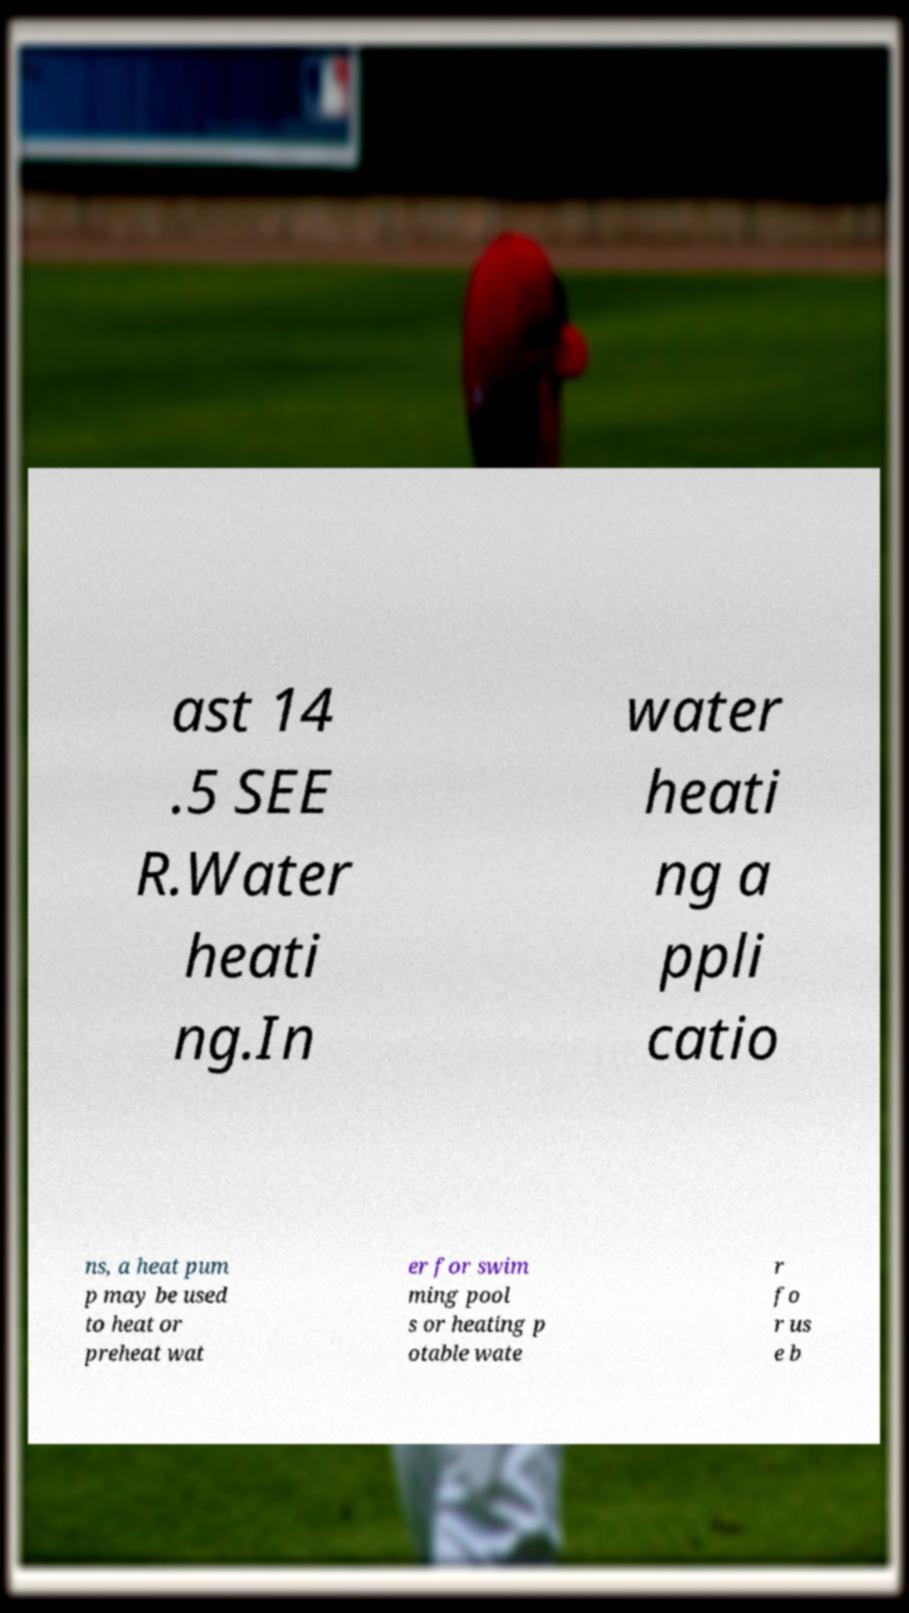What messages or text are displayed in this image? I need them in a readable, typed format. ast 14 .5 SEE R.Water heati ng.In water heati ng a ppli catio ns, a heat pum p may be used to heat or preheat wat er for swim ming pool s or heating p otable wate r fo r us e b 